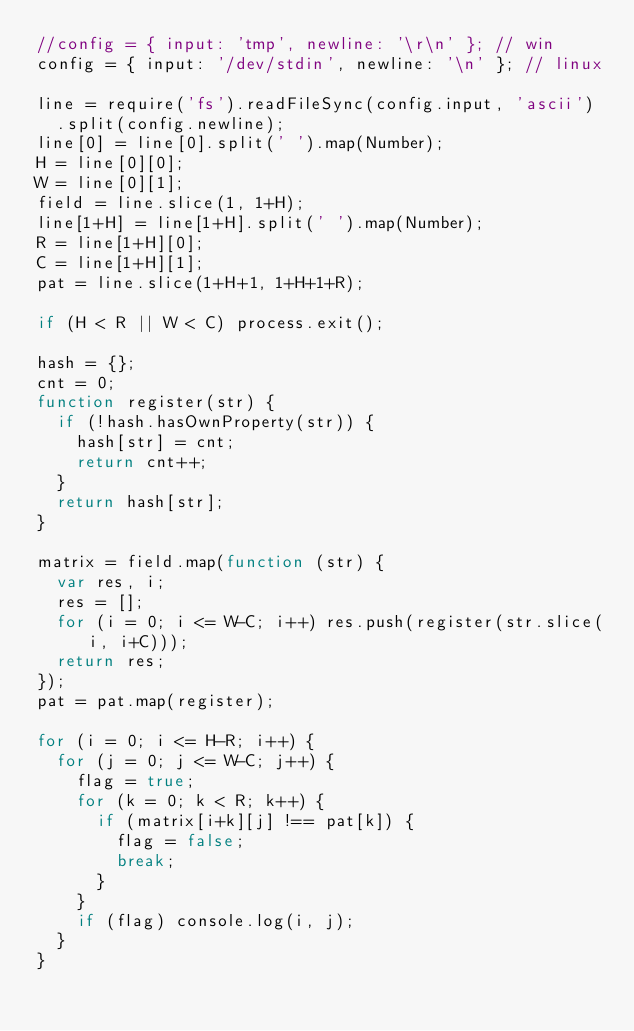Convert code to text. <code><loc_0><loc_0><loc_500><loc_500><_JavaScript_>//config = { input: 'tmp', newline: '\r\n' }; // win
config = { input: '/dev/stdin', newline: '\n' }; // linux

line = require('fs').readFileSync(config.input, 'ascii')
  .split(config.newline);
line[0] = line[0].split(' ').map(Number);
H = line[0][0];
W = line[0][1];
field = line.slice(1, 1+H);
line[1+H] = line[1+H].split(' ').map(Number);
R = line[1+H][0];
C = line[1+H][1];
pat = line.slice(1+H+1, 1+H+1+R);

if (H < R || W < C) process.exit();

hash = {};
cnt = 0;
function register(str) {
  if (!hash.hasOwnProperty(str)) {
    hash[str] = cnt;
    return cnt++;
  }
  return hash[str];
}

matrix = field.map(function (str) {
  var res, i;
  res = [];
  for (i = 0; i <= W-C; i++) res.push(register(str.slice(i, i+C)));
  return res;
});
pat = pat.map(register);

for (i = 0; i <= H-R; i++) {
  for (j = 0; j <= W-C; j++) {
    flag = true;
    for (k = 0; k < R; k++) {
      if (matrix[i+k][j] !== pat[k]) {
        flag = false;
        break;
      }
    }
    if (flag) console.log(i, j);
  }
}</code> 